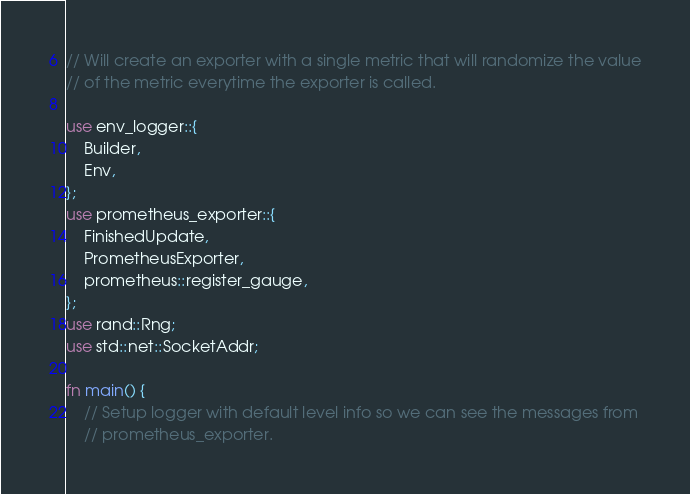Convert code to text. <code><loc_0><loc_0><loc_500><loc_500><_Rust_>// Will create an exporter with a single metric that will randomize the value
// of the metric everytime the exporter is called.

use env_logger::{
    Builder,
    Env,
};
use prometheus_exporter::{
    FinishedUpdate,
    PrometheusExporter,
    prometheus::register_gauge,
};
use rand::Rng;
use std::net::SocketAddr;

fn main() {
    // Setup logger with default level info so we can see the messages from
    // prometheus_exporter.</code> 